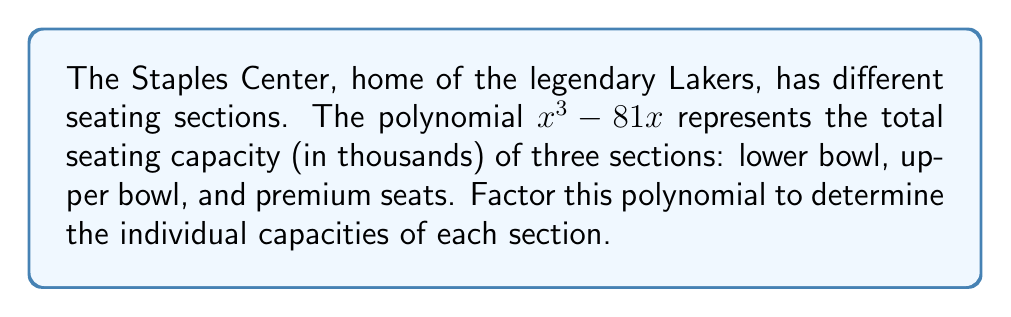Show me your answer to this math problem. Let's approach this step-by-step:

1) The polynomial we need to factor is $x^3 - 81x$.

2) This polynomial has a common factor of $x$. Let's factor it out:
   $x^3 - 81x = x(x^2 - 81)$

3) Now we have $x^2 - 81$ inside the parentheses. This is a difference of squares, which can be factored as $(a+b)(a-b)$ where $a^2$ is the first term and $b^2$ is the second term.

4) In this case, $a^2 = x^2$ and $b^2 = 81$
   So, $a = x$ and $b = 9$

5) Applying the difference of squares formula:
   $x(x^2 - 81) = x(x+9)(x-9)$

6) Therefore, the fully factored polynomial is $x(x+9)(x-9)$

In the context of the Staples Center seating:
- $x$ represents one section's capacity
- $(x+9)$ represents another section's capacity
- $(x-9)$ represents the third section's capacity

Each factor, when multiplied by 1000, gives the actual seating capacity for that section.
Answer: $x(x+9)(x-9)$ 